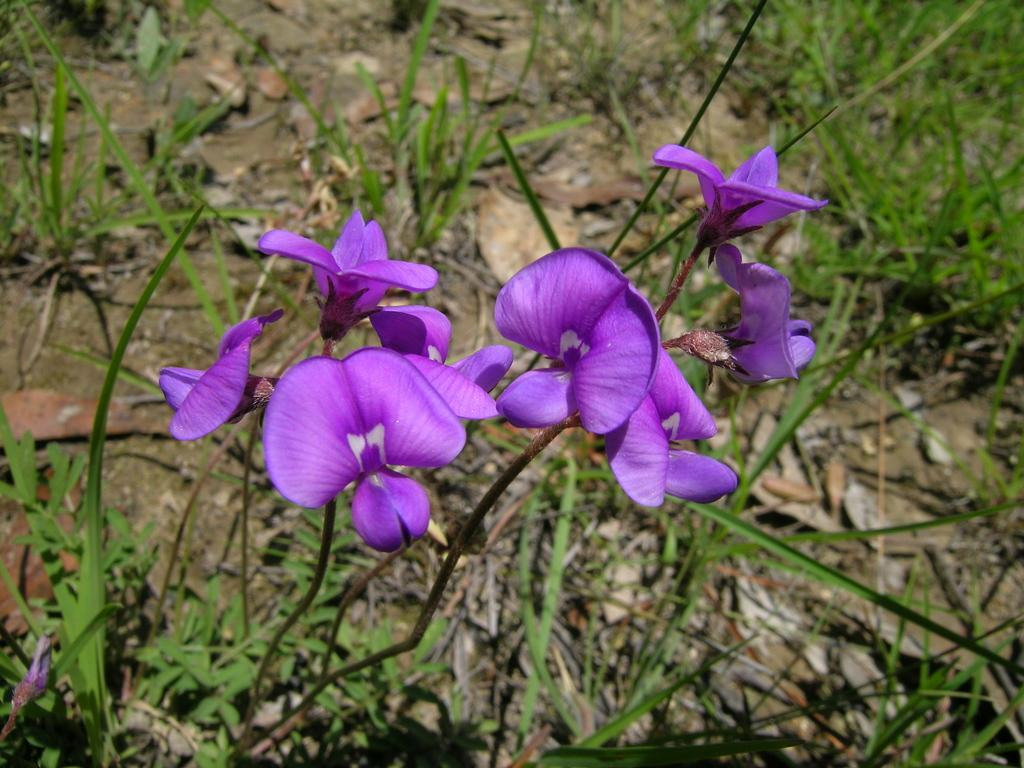What type of flowers can be seen in the image? There are purple color flowers in the image. What color are the leaves in the image? There are green color leaves in the image. What type of organization is depicted in the image? There is no organization depicted in the image; it features flowers and leaves. Can you see a rabbit or rat in the image? There is no rabbit or rat present in the image; it only contains flowers and leaves. 